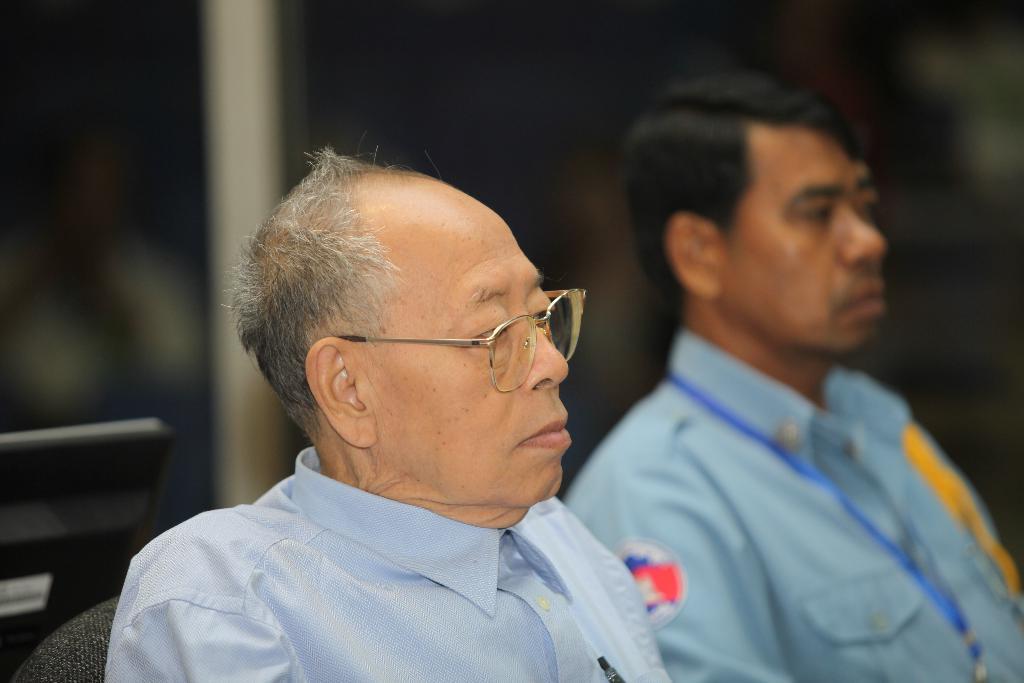Please provide a concise description of this image. In the foreground of this picture we can see a man wearing a shirt, spectacles and sitting on the chair. On the right there is a person wearing shirt and seems to be sitting. In the background we can see a metal rod and some other objects. The background of the image is blurry. 